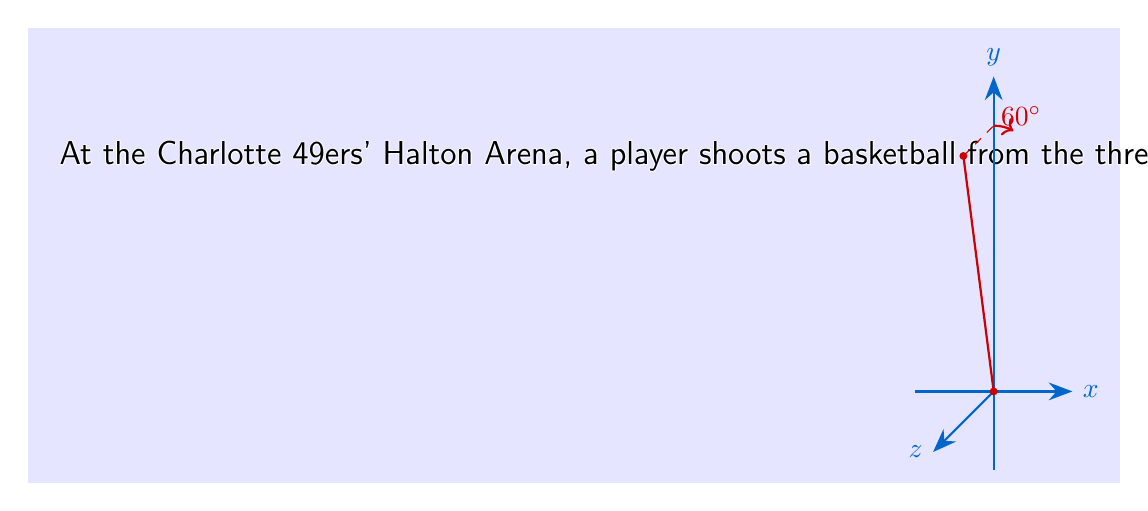What is the answer to this math problem? Let's approach this step-by-step:

1) First, we need to decompose the initial velocity into its x, y, and z components:

   $v_0 = 8$ m/s
   $\theta = 60°$ (angle from horizontal)
   $\phi = 10°$ (angle from direct path)

   $v_{0x} = v_0 \cos(\theta) \sin(\phi) = 8 \cos(60°) \sin(10°) = 0.696$ m/s
   $v_{0y} = v_0 \cos(\theta) \cos(\phi) = 8 \cos(60°) \cos(10°) = 3.943$ m/s
   $v_{0z} = v_0 \sin(\theta) = 8 \sin(60°) = 6.928$ m/s

2) Now, we can use the equations of motion for each component:

   $x(t) = x_0 + v_{0x}t$
   $y(t) = y_0 + v_{0y}t$
   $z(t) = z_0 + v_{0z}t - \frac{1}{2}gt^2$

3) Substituting the initial positions and velocities:

   $x(t) = 0 + 0.696t$
   $y(t) = 6.75 + 3.943t$
   $z(t) = 2 + 6.928t - \frac{1}{2}(9.8)t^2$

4) Simplifying:

   $x(t) = 0.696t$
   $y(t) = 6.75 + 3.943t$
   $z(t) = 2 + 6.928t - 4.9t^2$

5) The position vector r(t) is:

   $$\mathbf{r}(t) = \langle x(t), y(t), z(t) \rangle = \langle 0.696t, 6.75 + 3.943t, 2 + 6.928t - 4.9t^2 \rangle$$
Answer: $$\mathbf{r}(t) = \langle 0.696t, 6.75 + 3.943t, 2 + 6.928t - 4.9t^2 \rangle$$ 